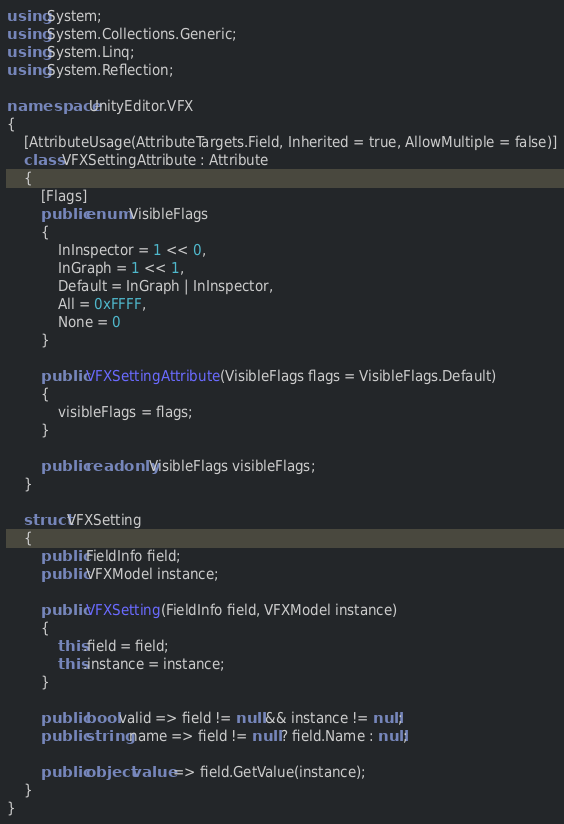Convert code to text. <code><loc_0><loc_0><loc_500><loc_500><_C#_>using System;
using System.Collections.Generic;
using System.Linq;
using System.Reflection;

namespace UnityEditor.VFX
{
    [AttributeUsage(AttributeTargets.Field, Inherited = true, AllowMultiple = false)]
    class VFXSettingAttribute : Attribute
    {
        [Flags]
        public enum VisibleFlags
        {
            InInspector = 1 << 0,
            InGraph = 1 << 1,
            Default = InGraph | InInspector,
            All = 0xFFFF,
            None = 0
        }

        public VFXSettingAttribute(VisibleFlags flags = VisibleFlags.Default)
        {
            visibleFlags = flags;
        }

        public readonly VisibleFlags visibleFlags;
    }

    struct VFXSetting
    {
        public FieldInfo field;
        public VFXModel instance;

        public VFXSetting(FieldInfo field, VFXModel instance)
        {
            this.field = field;
            this.instance = instance;
        }

        public bool valid => field != null && instance != null;
        public string name => field != null ? field.Name : null;

        public object value => field.GetValue(instance);
    }
}
</code> 